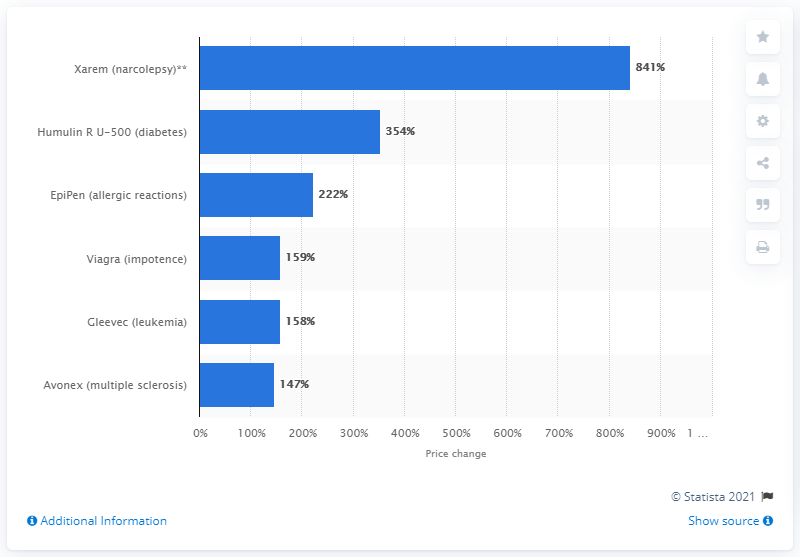Mention a couple of crucial points in this snapshot. The price of EpiPen increased by 222% from 2007 to 2014. 